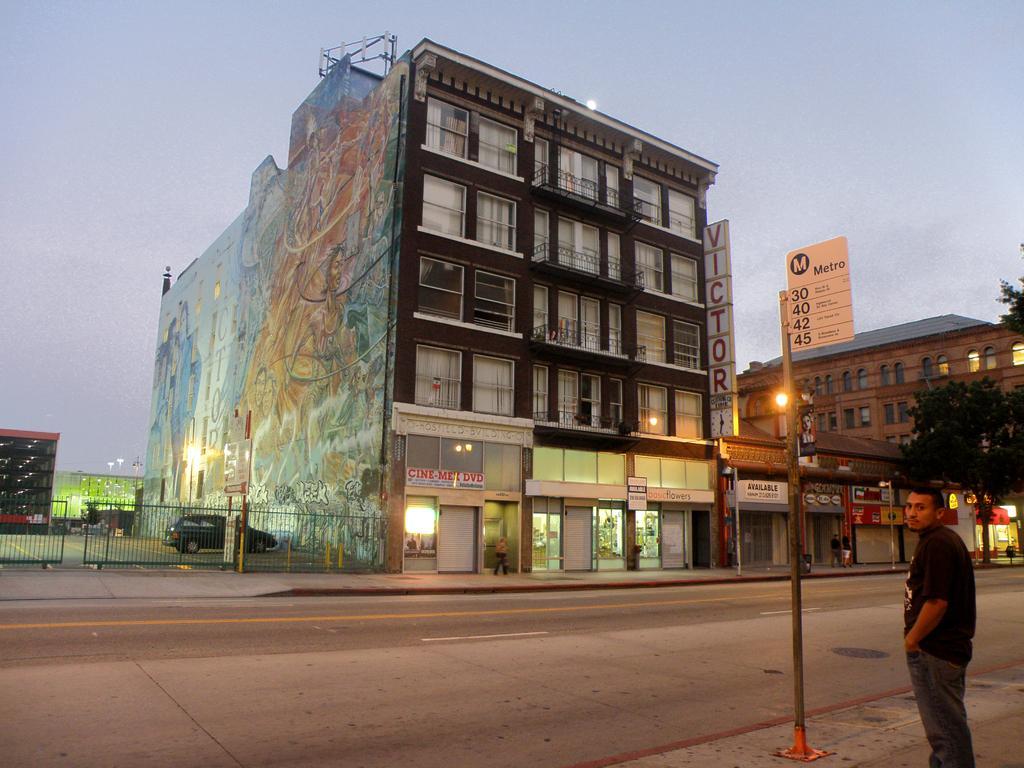How would you summarize this image in a sentence or two? In this image I can see the person standing. In the background I can see few poles, the railing, few vehicles, buildings in brown and cream color and I can see few stalls and the sky is in blue color. 